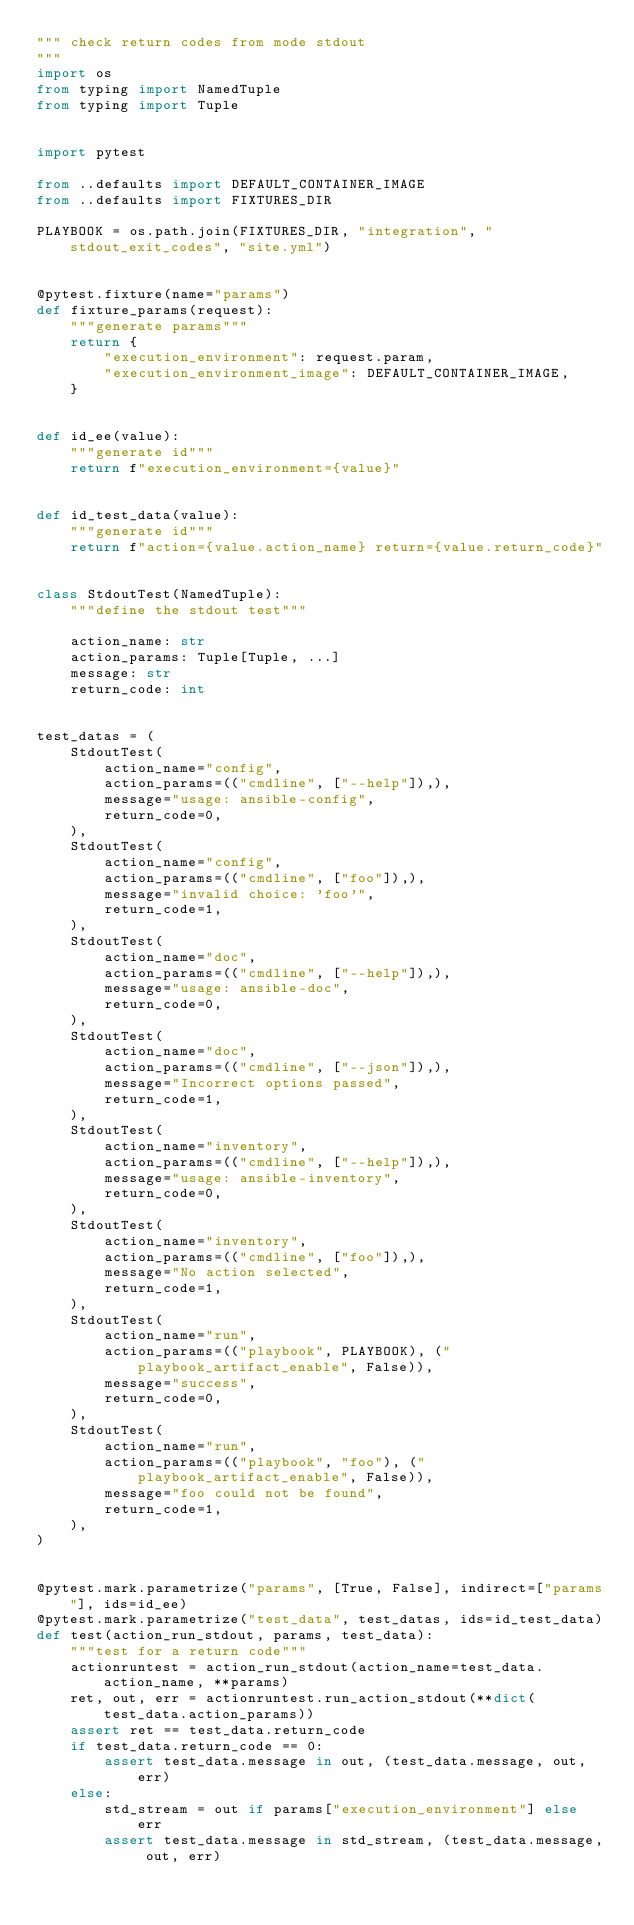Convert code to text. <code><loc_0><loc_0><loc_500><loc_500><_Python_>""" check return codes from mode stdout
"""
import os
from typing import NamedTuple
from typing import Tuple


import pytest

from ..defaults import DEFAULT_CONTAINER_IMAGE
from ..defaults import FIXTURES_DIR

PLAYBOOK = os.path.join(FIXTURES_DIR, "integration", "stdout_exit_codes", "site.yml")


@pytest.fixture(name="params")
def fixture_params(request):
    """generate params"""
    return {
        "execution_environment": request.param,
        "execution_environment_image": DEFAULT_CONTAINER_IMAGE,
    }


def id_ee(value):
    """generate id"""
    return f"execution_environment={value}"


def id_test_data(value):
    """generate id"""
    return f"action={value.action_name} return={value.return_code}"


class StdoutTest(NamedTuple):
    """define the stdout test"""

    action_name: str
    action_params: Tuple[Tuple, ...]
    message: str
    return_code: int


test_datas = (
    StdoutTest(
        action_name="config",
        action_params=(("cmdline", ["--help"]),),
        message="usage: ansible-config",
        return_code=0,
    ),
    StdoutTest(
        action_name="config",
        action_params=(("cmdline", ["foo"]),),
        message="invalid choice: 'foo'",
        return_code=1,
    ),
    StdoutTest(
        action_name="doc",
        action_params=(("cmdline", ["--help"]),),
        message="usage: ansible-doc",
        return_code=0,
    ),
    StdoutTest(
        action_name="doc",
        action_params=(("cmdline", ["--json"]),),
        message="Incorrect options passed",
        return_code=1,
    ),
    StdoutTest(
        action_name="inventory",
        action_params=(("cmdline", ["--help"]),),
        message="usage: ansible-inventory",
        return_code=0,
    ),
    StdoutTest(
        action_name="inventory",
        action_params=(("cmdline", ["foo"]),),
        message="No action selected",
        return_code=1,
    ),
    StdoutTest(
        action_name="run",
        action_params=(("playbook", PLAYBOOK), ("playbook_artifact_enable", False)),
        message="success",
        return_code=0,
    ),
    StdoutTest(
        action_name="run",
        action_params=(("playbook", "foo"), ("playbook_artifact_enable", False)),
        message="foo could not be found",
        return_code=1,
    ),
)


@pytest.mark.parametrize("params", [True, False], indirect=["params"], ids=id_ee)
@pytest.mark.parametrize("test_data", test_datas, ids=id_test_data)
def test(action_run_stdout, params, test_data):
    """test for a return code"""
    actionruntest = action_run_stdout(action_name=test_data.action_name, **params)
    ret, out, err = actionruntest.run_action_stdout(**dict(test_data.action_params))
    assert ret == test_data.return_code
    if test_data.return_code == 0:
        assert test_data.message in out, (test_data.message, out, err)
    else:
        std_stream = out if params["execution_environment"] else err
        assert test_data.message in std_stream, (test_data.message, out, err)
</code> 